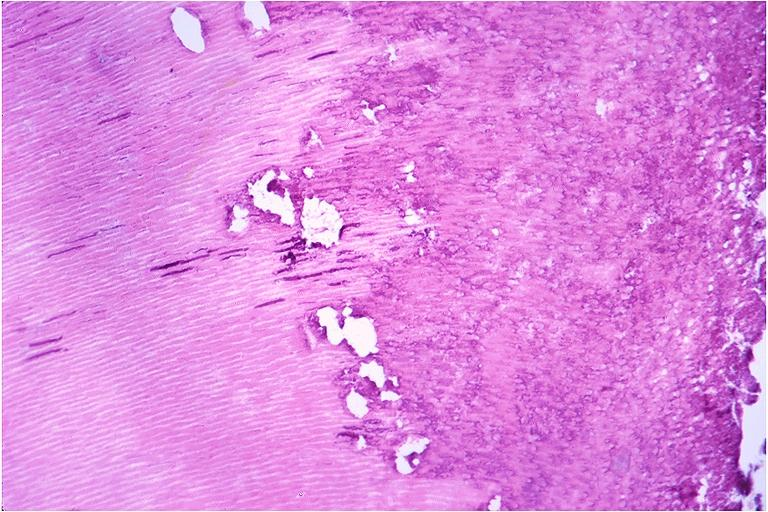s corpus luteum present?
Answer the question using a single word or phrase. No 